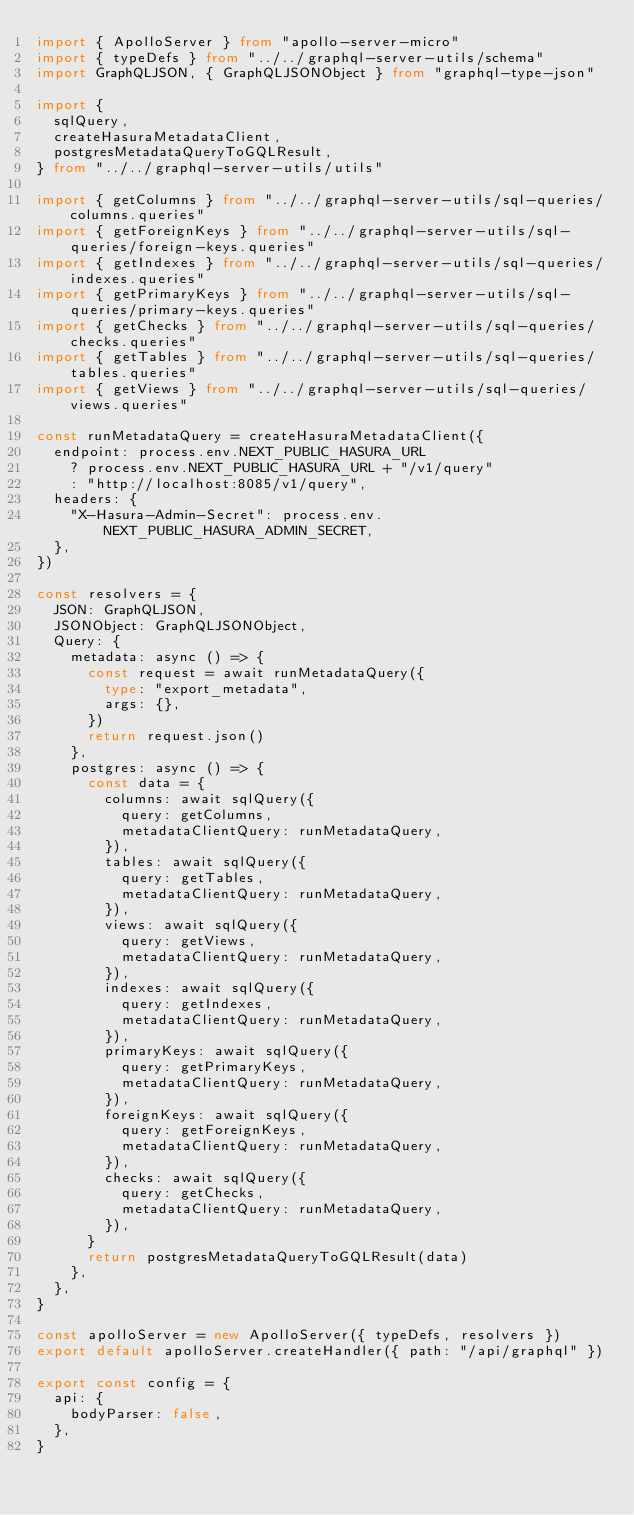Convert code to text. <code><loc_0><loc_0><loc_500><loc_500><_TypeScript_>import { ApolloServer } from "apollo-server-micro"
import { typeDefs } from "../../graphql-server-utils/schema"
import GraphQLJSON, { GraphQLJSONObject } from "graphql-type-json"

import {
  sqlQuery,
  createHasuraMetadataClient,
  postgresMetadataQueryToGQLResult,
} from "../../graphql-server-utils/utils"

import { getColumns } from "../../graphql-server-utils/sql-queries/columns.queries"
import { getForeignKeys } from "../../graphql-server-utils/sql-queries/foreign-keys.queries"
import { getIndexes } from "../../graphql-server-utils/sql-queries/indexes.queries"
import { getPrimaryKeys } from "../../graphql-server-utils/sql-queries/primary-keys.queries"
import { getChecks } from "../../graphql-server-utils/sql-queries/checks.queries"
import { getTables } from "../../graphql-server-utils/sql-queries/tables.queries"
import { getViews } from "../../graphql-server-utils/sql-queries/views.queries"

const runMetadataQuery = createHasuraMetadataClient({
  endpoint: process.env.NEXT_PUBLIC_HASURA_URL
    ? process.env.NEXT_PUBLIC_HASURA_URL + "/v1/query"
    : "http://localhost:8085/v1/query",
  headers: {
    "X-Hasura-Admin-Secret": process.env.NEXT_PUBLIC_HASURA_ADMIN_SECRET,
  },
})

const resolvers = {
  JSON: GraphQLJSON,
  JSONObject: GraphQLJSONObject,
  Query: {
    metadata: async () => {
      const request = await runMetadataQuery({
        type: "export_metadata",
        args: {},
      })
      return request.json()
    },
    postgres: async () => {
      const data = {
        columns: await sqlQuery({
          query: getColumns,
          metadataClientQuery: runMetadataQuery,
        }),
        tables: await sqlQuery({
          query: getTables,
          metadataClientQuery: runMetadataQuery,
        }),
        views: await sqlQuery({
          query: getViews,
          metadataClientQuery: runMetadataQuery,
        }),
        indexes: await sqlQuery({
          query: getIndexes,
          metadataClientQuery: runMetadataQuery,
        }),
        primaryKeys: await sqlQuery({
          query: getPrimaryKeys,
          metadataClientQuery: runMetadataQuery,
        }),
        foreignKeys: await sqlQuery({
          query: getForeignKeys,
          metadataClientQuery: runMetadataQuery,
        }),
        checks: await sqlQuery({
          query: getChecks,
          metadataClientQuery: runMetadataQuery,
        }),
      }
      return postgresMetadataQueryToGQLResult(data)
    },
  },
}

const apolloServer = new ApolloServer({ typeDefs, resolvers })
export default apolloServer.createHandler({ path: "/api/graphql" })

export const config = {
  api: {
    bodyParser: false,
  },
}
</code> 